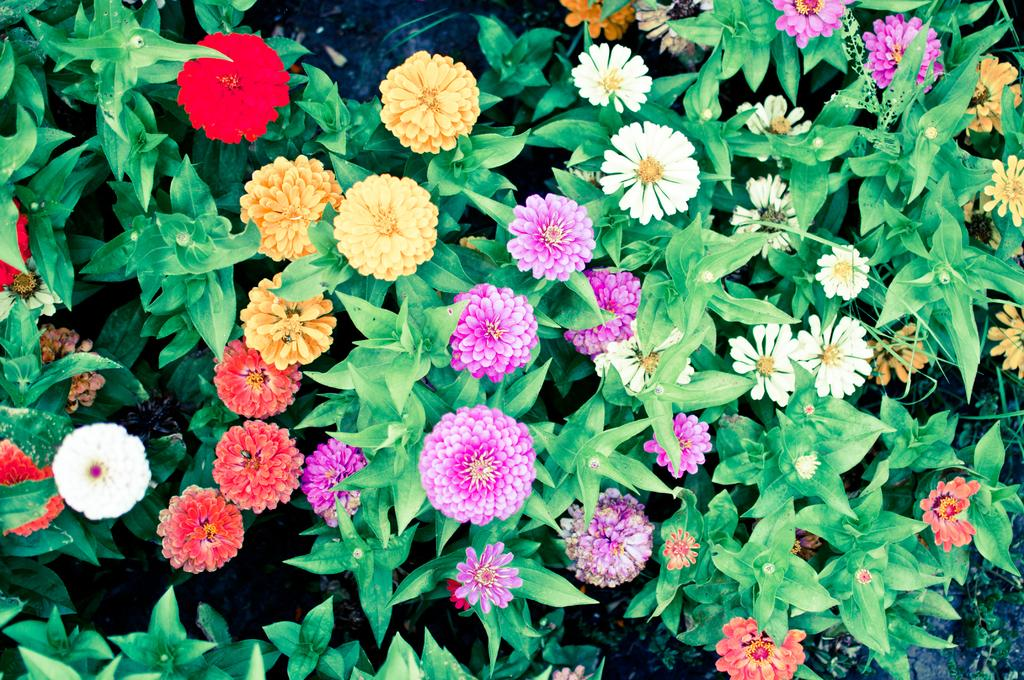What types of plants are present in the image? There are many flower plants in the image. Can you describe the flowers on the plants? The flower plants have different colored flowers. What type of apparel is the goose wearing in the image? There is no goose present in the image, and therefore no apparel can be observed. 